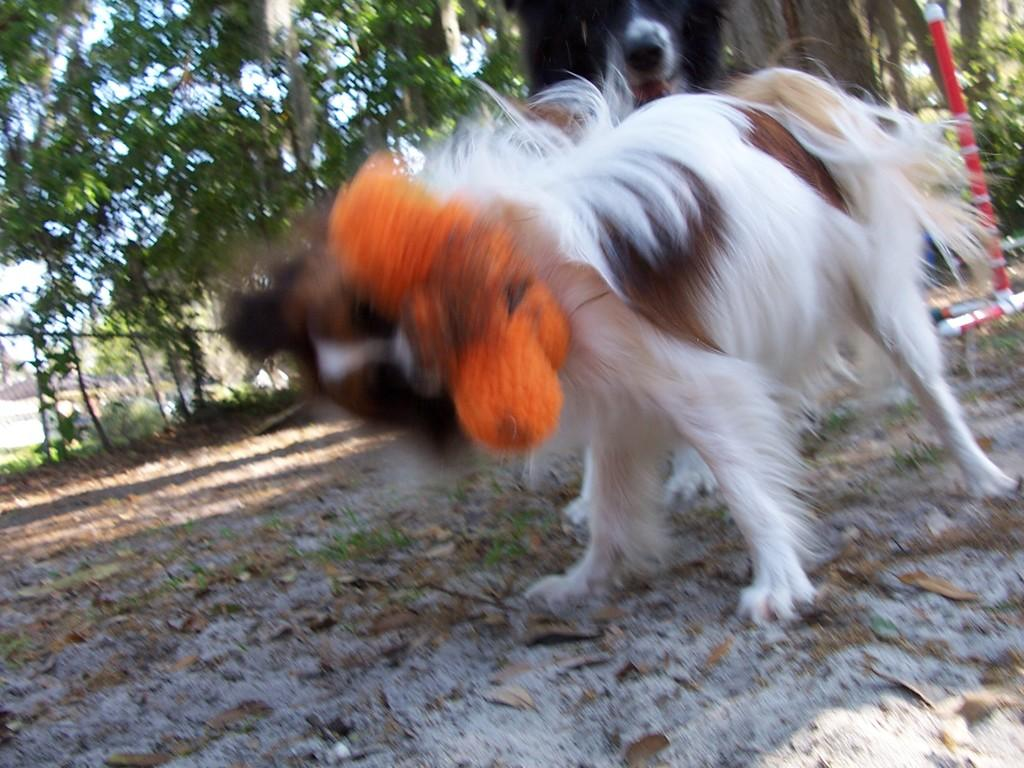What animal can be seen in the image? There is a dog in the image. Where is the dog located? The dog is on the ground. What can be seen in the background of the image? There are trees and a grilles gate visible in the background of the image. What type of wire is being used to hold the quince in the image? There is no wire or quince present in the image; it features a dog on the ground with trees and a grilles gate in the background. 